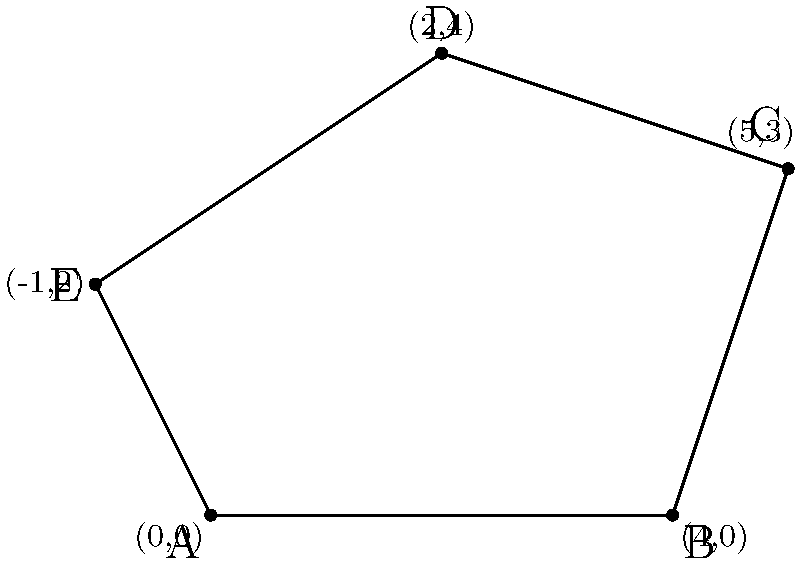As an i18n specialist, you're working on a mapping application that needs to calculate areas of irregular polygons across different European countries. Given the coordinates of an irregular pentagon in a Cartesian plane (in meters): A(0,0), B(4,0), C(5,3), D(2,4), and E(-1,2), calculate its area using the Shoelace formula. Round your answer to the nearest square meter. To calculate the area of an irregular polygon using the Shoelace formula:

1. Order the vertices either clockwise or counterclockwise.
2. Apply the formula: $Area = \frac{1}{2}|\sum_{i=1}^{n-1} (x_iy_{i+1} - x_{i+1}y_i) + (x_ny_1 - x_1y_n)|$

Where $(x_i, y_i)$ are the coordinates of the i-th vertex.

Substituting the given coordinates:

$Area = \frac{1}{2}|[(0 \cdot 0 - 4 \cdot 0) + (4 \cdot 3 - 5 \cdot 0) + (5 \cdot 4 - 2 \cdot 3) + (2 \cdot 2 - (-1) \cdot 4) + (-1 \cdot 0 - 0 \cdot 2)]|$

$= \frac{1}{2}|[0 + 12 + 14 + 8 + 0]|$

$= \frac{1}{2}|34|$

$= 17$ square meters

Therefore, the area of the irregular pentagon is 17 square meters.
Answer: 17 m² 